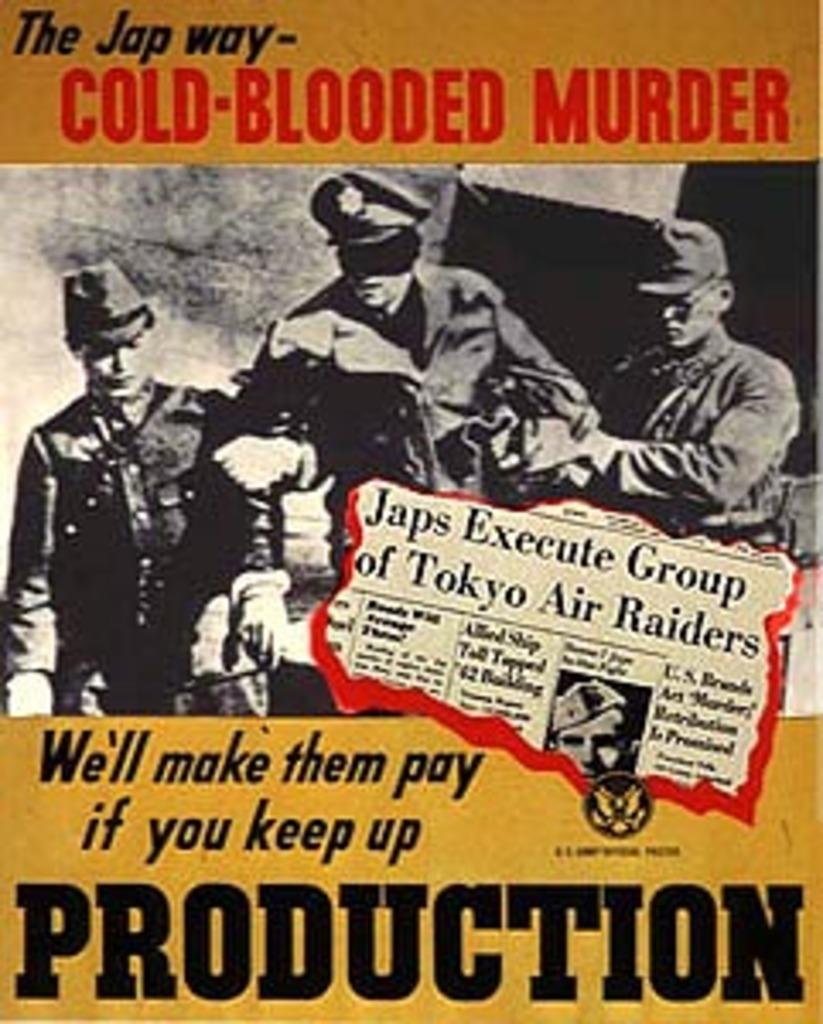What is depicted on the poster in the image? The poster features three men in the image. What are the men wearing in the poster? The men are wearing uniforms and caps in the poster. What is written on the poster? The poster has the text "Cold Blooded Murder" on it. What type of club is being promoted in the poster? There is no club being promoted in the poster; it features the text "Cold Blooded Murder." 